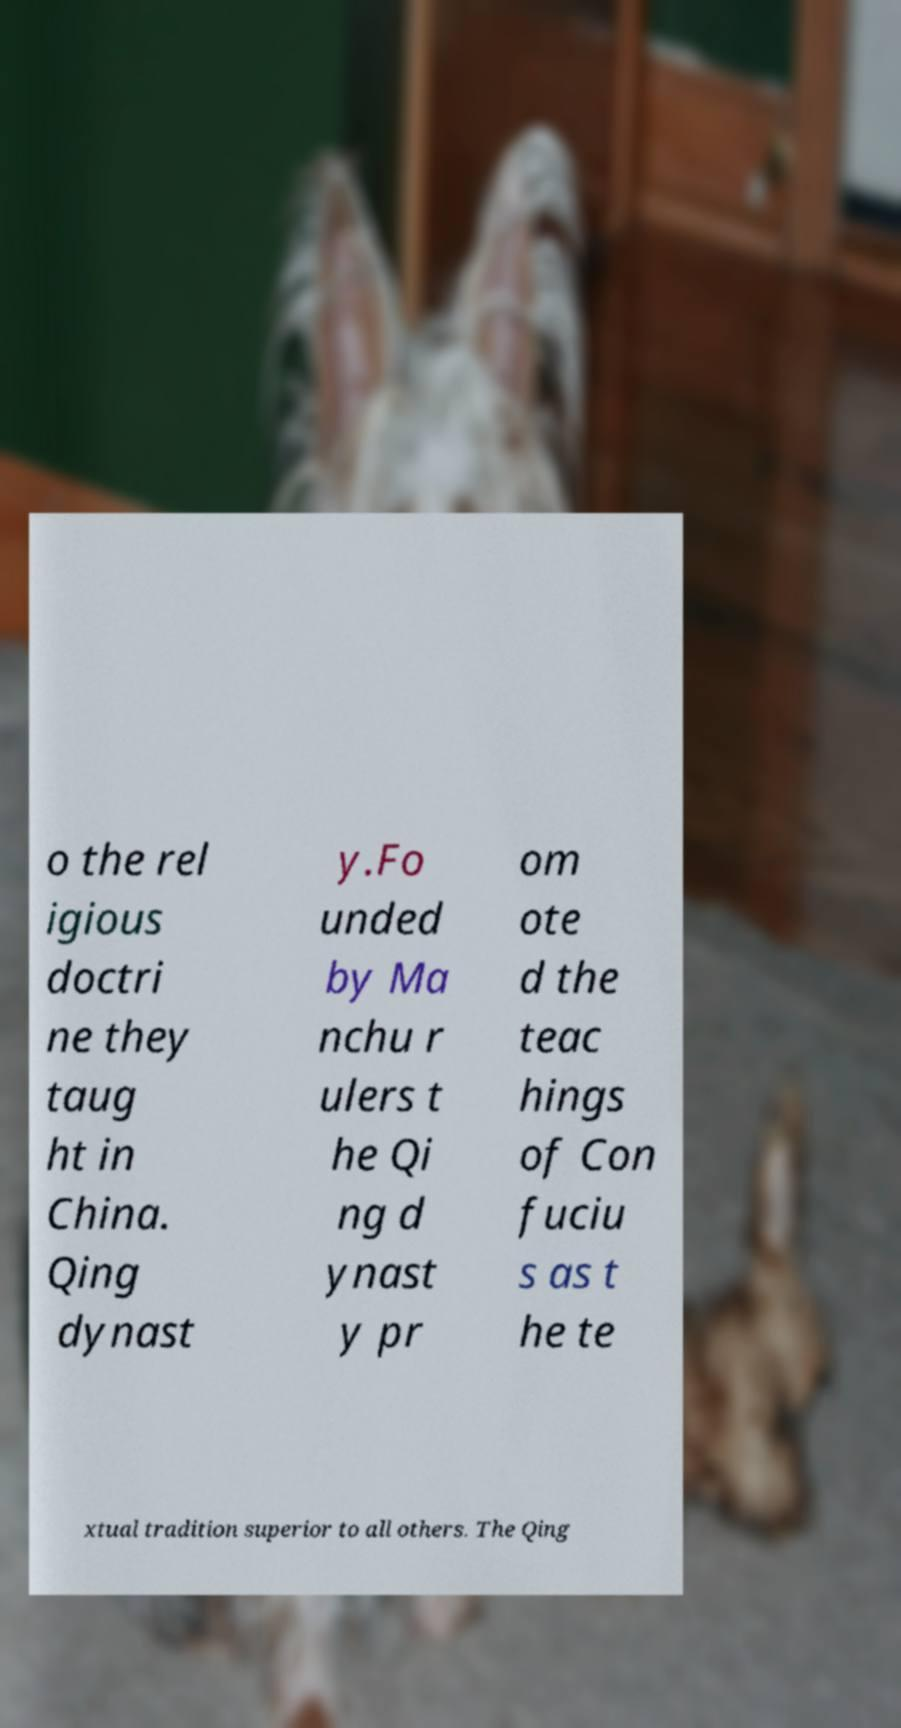There's text embedded in this image that I need extracted. Can you transcribe it verbatim? o the rel igious doctri ne they taug ht in China. Qing dynast y.Fo unded by Ma nchu r ulers t he Qi ng d ynast y pr om ote d the teac hings of Con fuciu s as t he te xtual tradition superior to all others. The Qing 